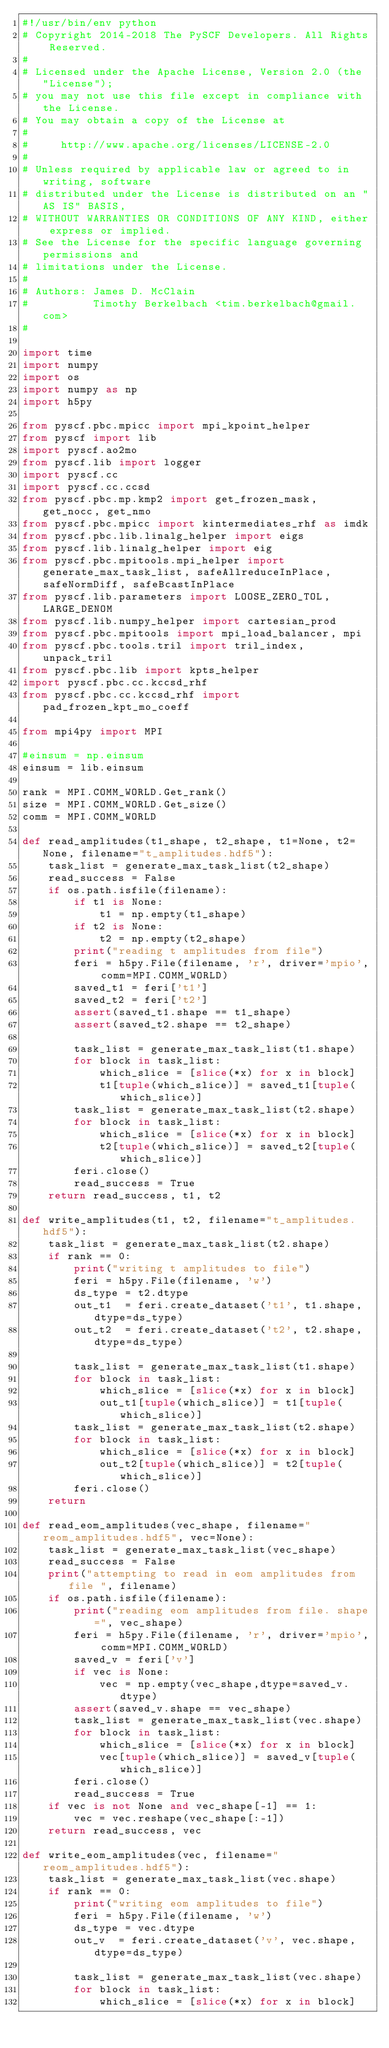<code> <loc_0><loc_0><loc_500><loc_500><_Python_>#!/usr/bin/env python
# Copyright 2014-2018 The PySCF Developers. All Rights Reserved.
#
# Licensed under the Apache License, Version 2.0 (the "License");
# you may not use this file except in compliance with the License.
# You may obtain a copy of the License at
#
#     http://www.apache.org/licenses/LICENSE-2.0
#
# Unless required by applicable law or agreed to in writing, software
# distributed under the License is distributed on an "AS IS" BASIS,
# WITHOUT WARRANTIES OR CONDITIONS OF ANY KIND, either express or implied.
# See the License for the specific language governing permissions and
# limitations under the License.
#
# Authors: James D. McClain
#          Timothy Berkelbach <tim.berkelbach@gmail.com>
#

import time
import numpy
import os
import numpy as np
import h5py

from pyscf.pbc.mpicc import mpi_kpoint_helper
from pyscf import lib
import pyscf.ao2mo
from pyscf.lib import logger
import pyscf.cc
import pyscf.cc.ccsd
from pyscf.pbc.mp.kmp2 import get_frozen_mask, get_nocc, get_nmo
from pyscf.pbc.mpicc import kintermediates_rhf as imdk
from pyscf.pbc.lib.linalg_helper import eigs
from pyscf.lib.linalg_helper import eig
from pyscf.pbc.mpitools.mpi_helper import generate_max_task_list, safeAllreduceInPlace, safeNormDiff, safeBcastInPlace
from pyscf.lib.parameters import LOOSE_ZERO_TOL, LARGE_DENOM
from pyscf.lib.numpy_helper import cartesian_prod
from pyscf.pbc.mpitools import mpi_load_balancer, mpi
from pyscf.pbc.tools.tril import tril_index, unpack_tril
from pyscf.pbc.lib import kpts_helper
import pyscf.pbc.cc.kccsd_rhf
from pyscf.pbc.cc.kccsd_rhf import pad_frozen_kpt_mo_coeff

from mpi4py import MPI

#einsum = np.einsum
einsum = lib.einsum

rank = MPI.COMM_WORLD.Get_rank()
size = MPI.COMM_WORLD.Get_size()
comm = MPI.COMM_WORLD

def read_amplitudes(t1_shape, t2_shape, t1=None, t2=None, filename="t_amplitudes.hdf5"):
    task_list = generate_max_task_list(t2_shape)
    read_success = False
    if os.path.isfile(filename):
        if t1 is None:
            t1 = np.empty(t1_shape)
        if t2 is None:
            t2 = np.empty(t2_shape)
        print("reading t amplitudes from file")
        feri = h5py.File(filename, 'r', driver='mpio', comm=MPI.COMM_WORLD)
        saved_t1 = feri['t1']
        saved_t2 = feri['t2']
        assert(saved_t1.shape == t1_shape)
        assert(saved_t2.shape == t2_shape)

        task_list = generate_max_task_list(t1.shape)
        for block in task_list:
            which_slice = [slice(*x) for x in block]
            t1[tuple(which_slice)] = saved_t1[tuple(which_slice)]
        task_list = generate_max_task_list(t2.shape)
        for block in task_list:
            which_slice = [slice(*x) for x in block]
            t2[tuple(which_slice)] = saved_t2[tuple(which_slice)]
        feri.close()
        read_success = True
    return read_success, t1, t2

def write_amplitudes(t1, t2, filename="t_amplitudes.hdf5"):
    task_list = generate_max_task_list(t2.shape)
    if rank == 0:
        print("writing t amplitudes to file")
        feri = h5py.File(filename, 'w')
        ds_type = t2.dtype
        out_t1  = feri.create_dataset('t1', t1.shape, dtype=ds_type)
        out_t2  = feri.create_dataset('t2', t2.shape, dtype=ds_type)

        task_list = generate_max_task_list(t1.shape)
        for block in task_list:
            which_slice = [slice(*x) for x in block]
            out_t1[tuple(which_slice)] = t1[tuple(which_slice)]
        task_list = generate_max_task_list(t2.shape)
        for block in task_list:
            which_slice = [slice(*x) for x in block]
            out_t2[tuple(which_slice)] = t2[tuple(which_slice)]
        feri.close()
    return

def read_eom_amplitudes(vec_shape, filename="reom_amplitudes.hdf5", vec=None):
    task_list = generate_max_task_list(vec_shape)
    read_success = False
    print("attempting to read in eom amplitudes from file ", filename)
    if os.path.isfile(filename):
        print("reading eom amplitudes from file. shape=", vec_shape)
        feri = h5py.File(filename, 'r', driver='mpio', comm=MPI.COMM_WORLD)
        saved_v = feri['v']
        if vec is None:
            vec = np.empty(vec_shape,dtype=saved_v.dtype)
        assert(saved_v.shape == vec_shape)
        task_list = generate_max_task_list(vec.shape)
        for block in task_list:
            which_slice = [slice(*x) for x in block]
            vec[tuple(which_slice)] = saved_v[tuple(which_slice)]
        feri.close()
        read_success = True
    if vec is not None and vec_shape[-1] == 1:
        vec = vec.reshape(vec_shape[:-1])
    return read_success, vec

def write_eom_amplitudes(vec, filename="reom_amplitudes.hdf5"):
    task_list = generate_max_task_list(vec.shape)
    if rank == 0:
        print("writing eom amplitudes to file")
        feri = h5py.File(filename, 'w')
        ds_type = vec.dtype
        out_v  = feri.create_dataset('v', vec.shape, dtype=ds_type)

        task_list = generate_max_task_list(vec.shape)
        for block in task_list:
            which_slice = [slice(*x) for x in block]</code> 